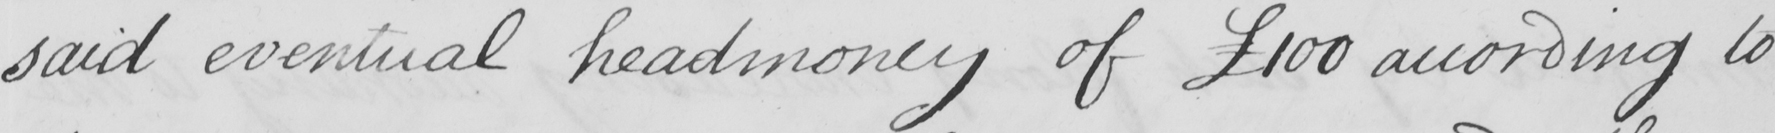What is written in this line of handwriting? said eventual headmoney of  £100 according to 